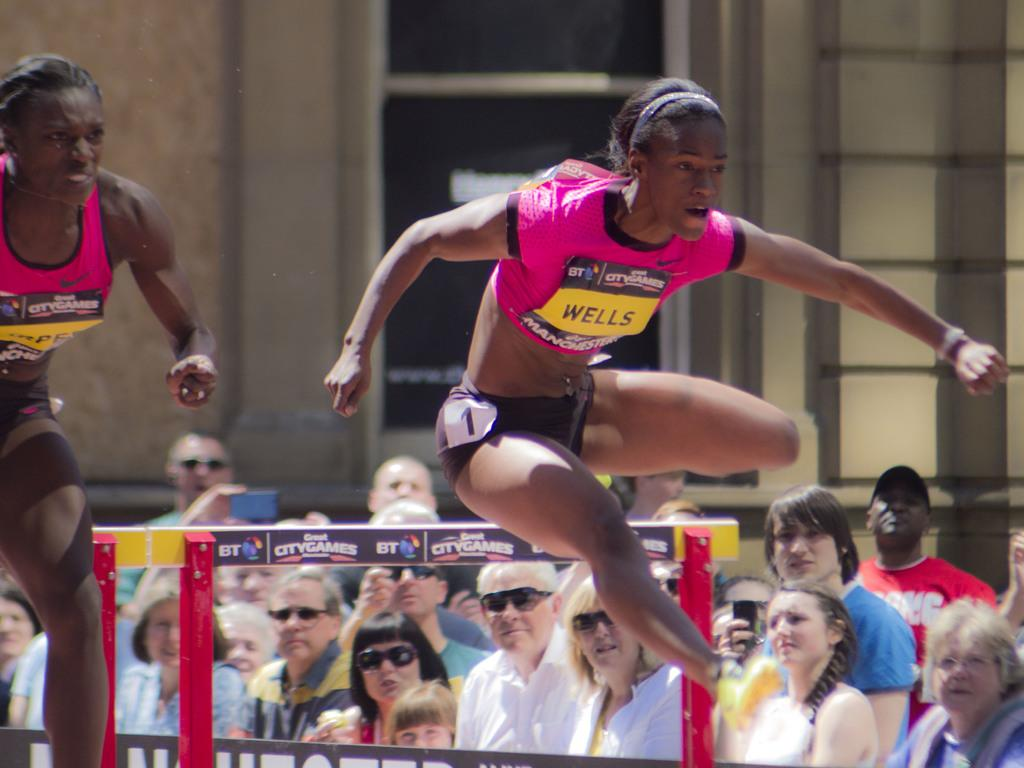What is the woman in the pink T-shirt doing in the image? There is a woman in a pink T-shirt jumping and running in the image. What are the people in the image doing? People are watching the women in the image. What can be seen in the background of the image? There is a wall and a window in the background of the image. What type of ship can be seen sailing in the background of the image? There is no ship present in the image; it features a woman in a pink T-shirt jumping and running, people watching her, and a wall and window in the background. 